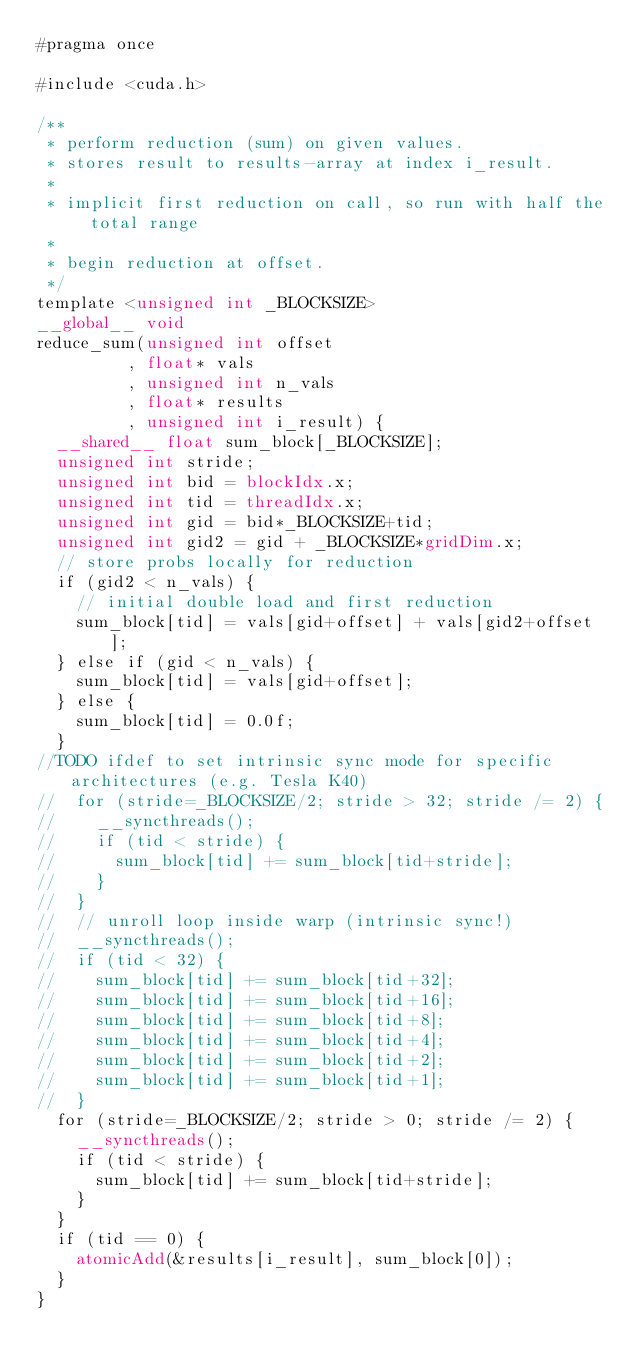<code> <loc_0><loc_0><loc_500><loc_500><_Cuda_>#pragma once

#include <cuda.h>

/**
 * perform reduction (sum) on given values.
 * stores result to results-array at index i_result.
 *
 * implicit first reduction on call, so run with half the total range
 *
 * begin reduction at offset.
 */
template <unsigned int _BLOCKSIZE>
__global__ void
reduce_sum(unsigned int offset
         , float* vals
         , unsigned int n_vals
         , float* results
         , unsigned int i_result) {
  __shared__ float sum_block[_BLOCKSIZE];
  unsigned int stride;
  unsigned int bid = blockIdx.x;
  unsigned int tid = threadIdx.x;
  unsigned int gid = bid*_BLOCKSIZE+tid;
  unsigned int gid2 = gid + _BLOCKSIZE*gridDim.x;
  // store probs locally for reduction
  if (gid2 < n_vals) {
    // initial double load and first reduction
    sum_block[tid] = vals[gid+offset] + vals[gid2+offset];
  } else if (gid < n_vals) {
    sum_block[tid] = vals[gid+offset];
  } else {
    sum_block[tid] = 0.0f;
  }
//TODO ifdef to set intrinsic sync mode for specific architectures (e.g. Tesla K40)
//  for (stride=_BLOCKSIZE/2; stride > 32; stride /= 2) {
//    __syncthreads();
//    if (tid < stride) {
//      sum_block[tid] += sum_block[tid+stride];
//    }
//  }
//  // unroll loop inside warp (intrinsic sync!)
//  __syncthreads();
//  if (tid < 32) {
//    sum_block[tid] += sum_block[tid+32];
//    sum_block[tid] += sum_block[tid+16];
//    sum_block[tid] += sum_block[tid+8];
//    sum_block[tid] += sum_block[tid+4];
//    sum_block[tid] += sum_block[tid+2];
//    sum_block[tid] += sum_block[tid+1];
//  }
  for (stride=_BLOCKSIZE/2; stride > 0; stride /= 2) {
    __syncthreads();
    if (tid < stride) {
      sum_block[tid] += sum_block[tid+stride];
    }
  }
  if (tid == 0) {
    atomicAdd(&results[i_result], sum_block[0]);
  }
}

</code> 